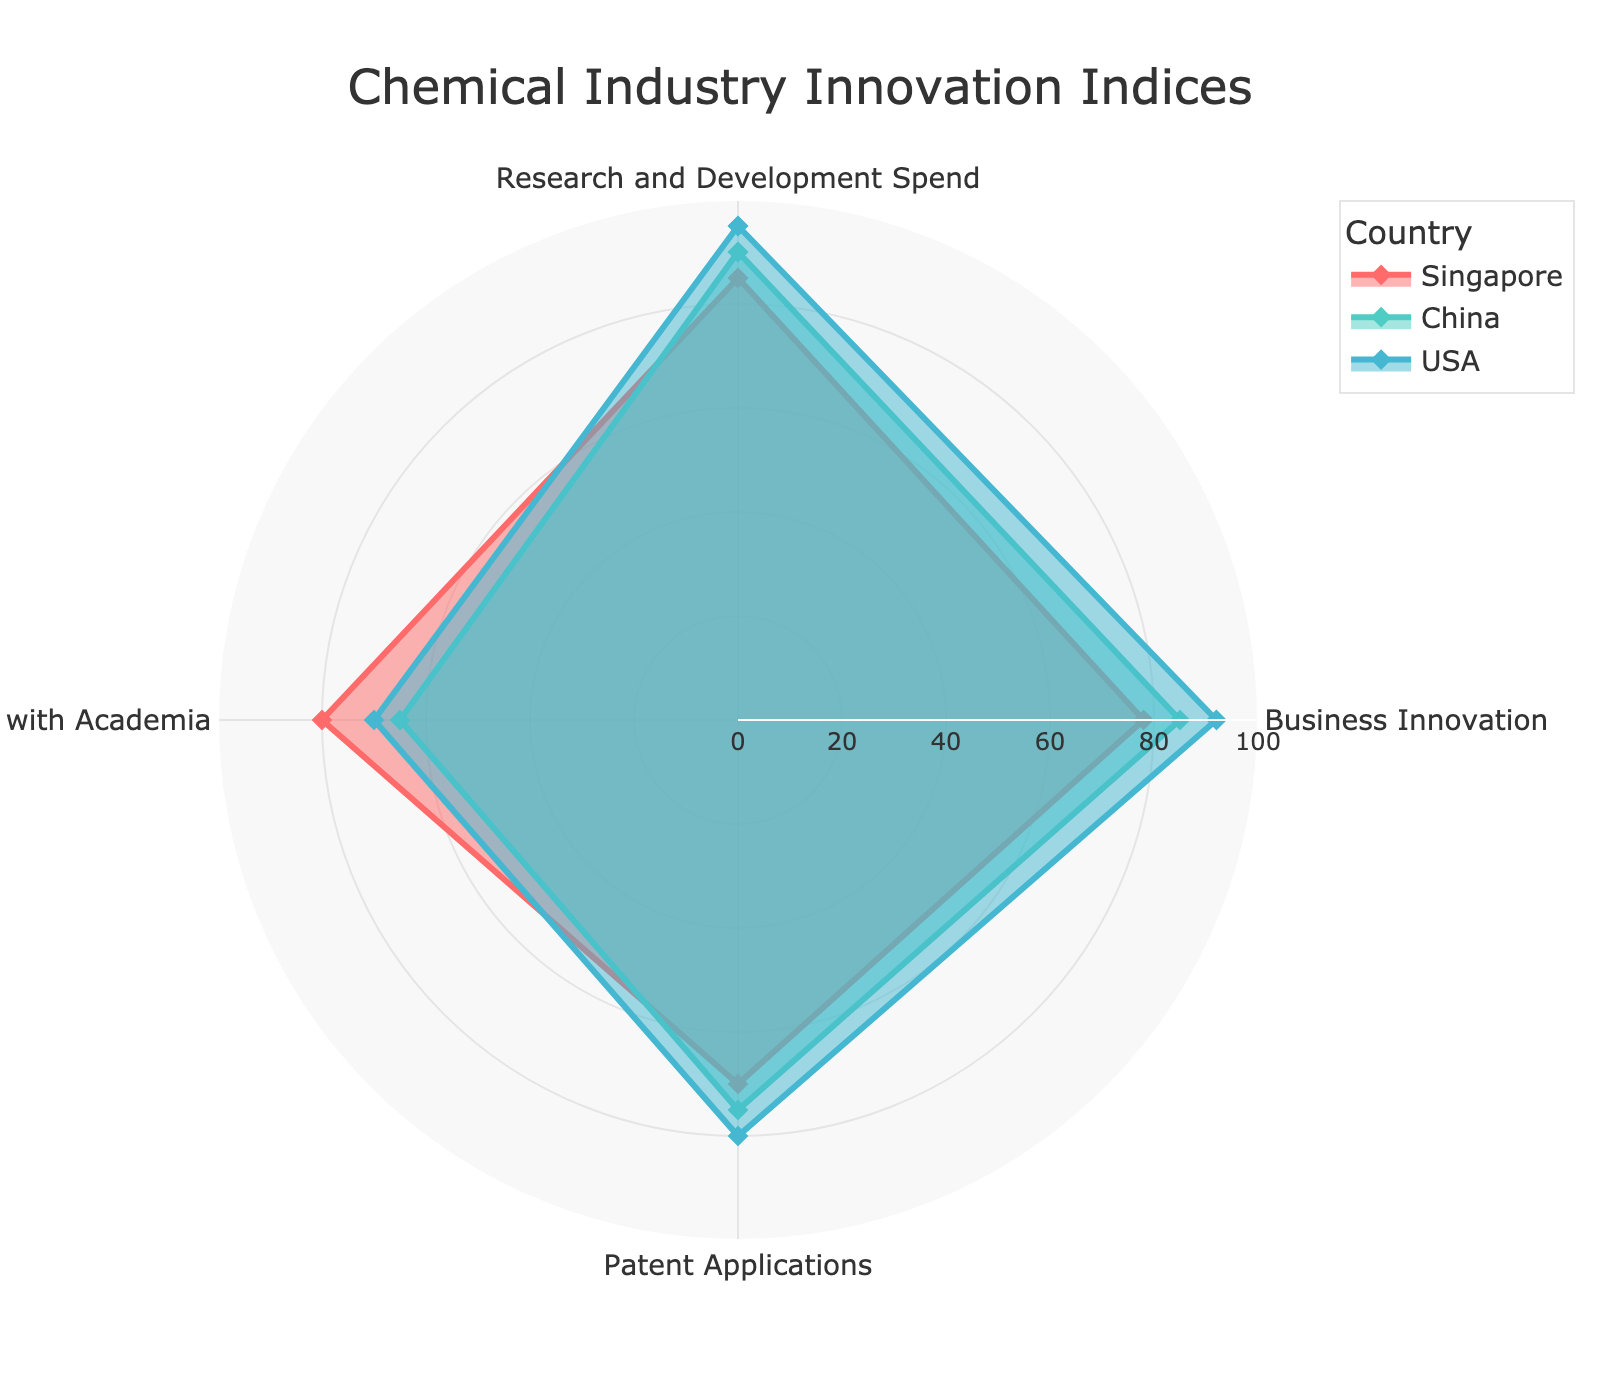What's the title of the radar chart? The title of the radar chart is displayed prominently at the top of the figure. It provides a concise description of the data being visualized.
Answer: Chemical Industry Innovation Indices Which country shows the highest value for Patent Applications? In the radar chart, locate the label for Patent Applications. Then, identify the country represented by the outermost data point in this section.
Answer: USA What is the average of the Research and Development Spend values for Singapore and China? The Research and Development Spend values for these countries are 85 for Singapore and 90 for China. Add these values together and divide by 2 to calculate the average: (85 + 90) / 2 = 87.5.
Answer: 87.5 Which country has the lowest Collaboration with Academia score? Locate the section of the radar chart labeled Collaboration with Academia. Then identify the country represented by the innermost data point in this section.
Answer: China Compare the Business Innovation scores between Singapore and the USA. Which country has a higher score? Identify the Business Innovation section in the chart. Compare the positions of the data points for Singapore and the USA within this section. The outermost point has the higher score.
Answer: USA What is the sum of the Business Innovation and Patent Applications scores for China? For China, the Business Innovation score is 85 and the Patent Applications score is 75. Add these values together: 85 + 75 = 160.
Answer: 160 How does Singapore's average score across all indices compare to the USA's average score? Calculate Singapore's average by summing its scores (85, 78, 70, 80) and dividing by 4. Do the same for the USA's scores (95, 92, 80, 70). Singapore: (85 + 78 + 70 + 80) / 4 = 78.25; USA: (95 + 92 + 80 + 70) / 4 = 84.25. Compare these averages.
Answer: Singapore: 78.25, USA: 84.25 Which country has the highest overall performance based on the sum of all indices? Calculate the sum of all index values for each country. Singapore: 85 + 78 + 70 + 80 = 313, China: 90 + 85 + 75 + 65 = 315, USA: 95 + 92 + 80 + 70 = 337. The country with the highest sum has the highest overall performance.
Answer: USA 